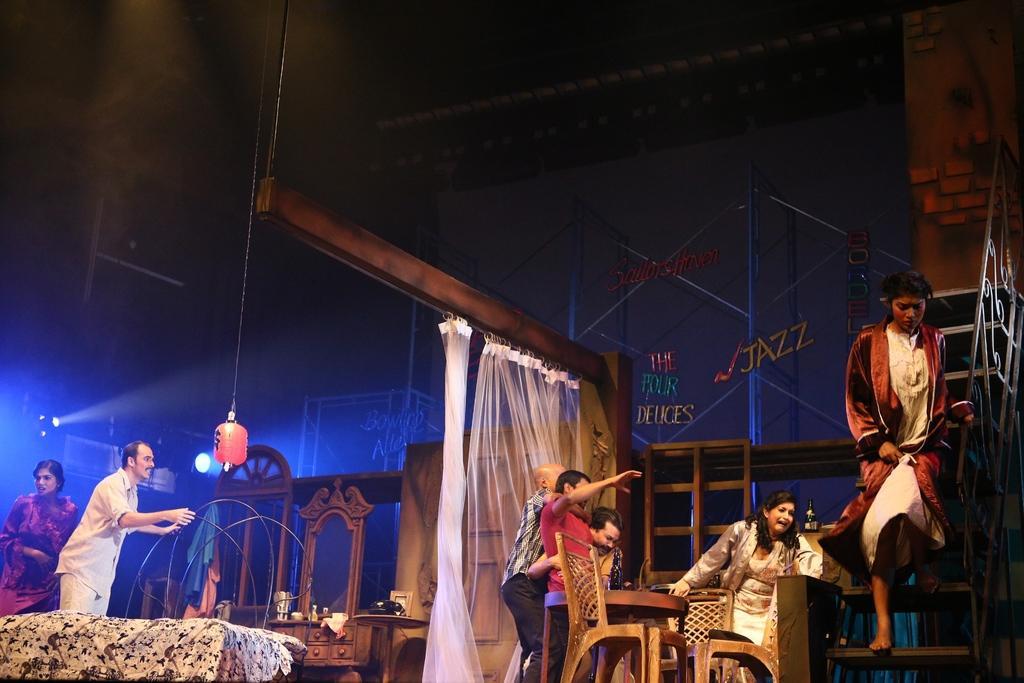Describe this image in one or two sentences. Right a woman is moving from the staircase beside her another woman is shouting she wears a white colour dress and there are chairs and tables at here and a man is standing at here in the left there is a bad dressing table and a man is standing at here. At the left there is a light. 